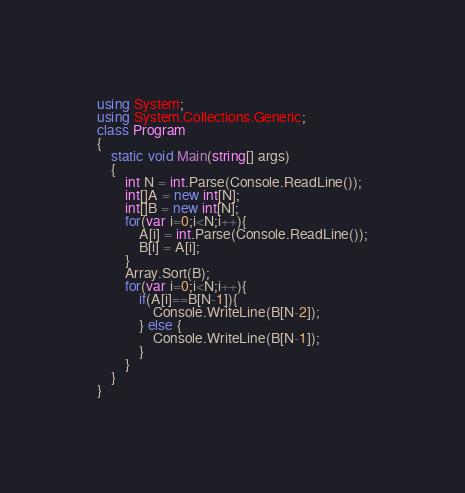Convert code to text. <code><loc_0><loc_0><loc_500><loc_500><_C#_>using System;
using System.Collections.Generic;
class Program
{
	static void Main(string[] args)
	{
		int N = int.Parse(Console.ReadLine());
		int[]A = new int[N];
		int[]B = new int[N];
		for(var i=0;i<N;i++){
			A[i] = int.Parse(Console.ReadLine());
			B[i] = A[i];
		}
		Array.Sort(B);
		for(var i=0;i<N;i++){
			if(A[i]==B[N-1]){
				Console.WriteLine(B[N-2]);
			} else {
				Console.WriteLine(B[N-1]);
			}
		}
	}
}</code> 